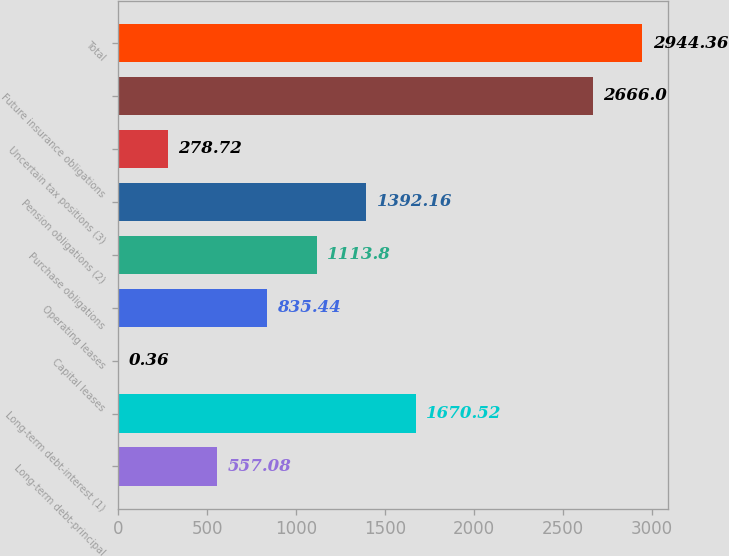Convert chart. <chart><loc_0><loc_0><loc_500><loc_500><bar_chart><fcel>Long-term debt-principal<fcel>Long-term debt-interest (1)<fcel>Capital leases<fcel>Operating leases<fcel>Purchase obligations<fcel>Pension obligations (2)<fcel>Uncertain tax positions (3)<fcel>Future insurance obligations<fcel>Total<nl><fcel>557.08<fcel>1670.52<fcel>0.36<fcel>835.44<fcel>1113.8<fcel>1392.16<fcel>278.72<fcel>2666<fcel>2944.36<nl></chart> 